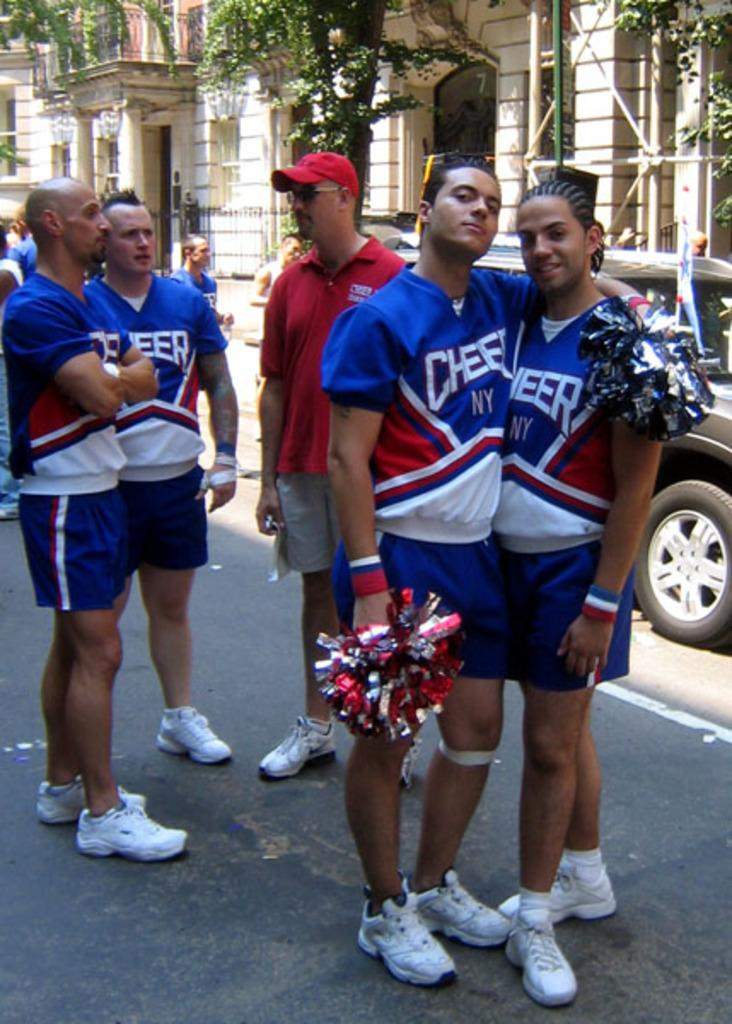What is happening in the center of the image? There is a group of persons standing on the road in the center of the image. What can be seen in the background of the image? There is a car and a building in the background of the image. What type of party is the giraffe attending in the image? There is no giraffe present in the image, and therefore no party or gathering involving a giraffe can be observed. 